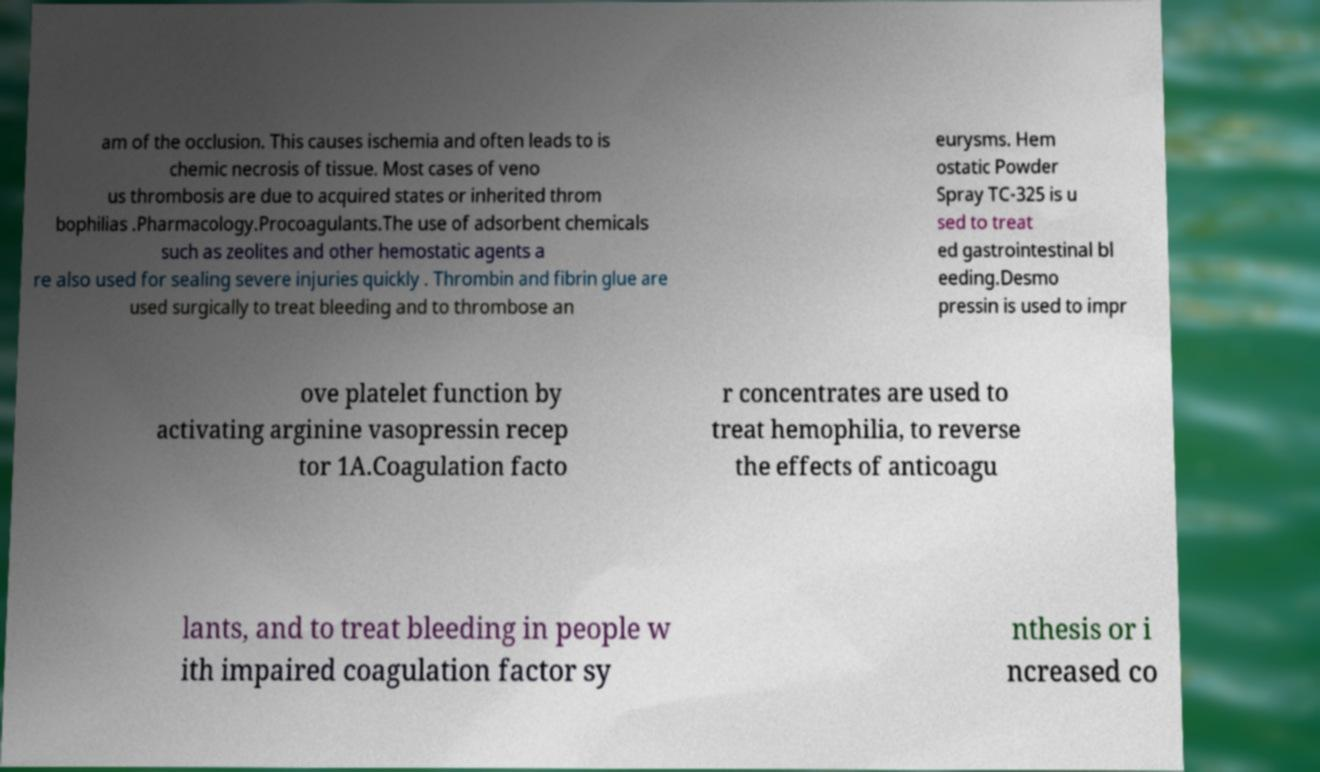What messages or text are displayed in this image? I need them in a readable, typed format. am of the occlusion. This causes ischemia and often leads to is chemic necrosis of tissue. Most cases of veno us thrombosis are due to acquired states or inherited throm bophilias .Pharmacology.Procoagulants.The use of adsorbent chemicals such as zeolites and other hemostatic agents a re also used for sealing severe injuries quickly . Thrombin and fibrin glue are used surgically to treat bleeding and to thrombose an eurysms. Hem ostatic Powder Spray TC-325 is u sed to treat ed gastrointestinal bl eeding.Desmo pressin is used to impr ove platelet function by activating arginine vasopressin recep tor 1A.Coagulation facto r concentrates are used to treat hemophilia, to reverse the effects of anticoagu lants, and to treat bleeding in people w ith impaired coagulation factor sy nthesis or i ncreased co 